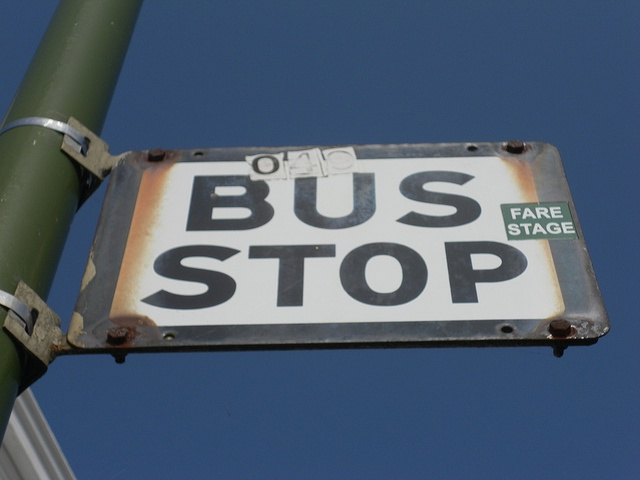Describe the objects in this image and their specific colors. I can see various objects in this image with different colors. 